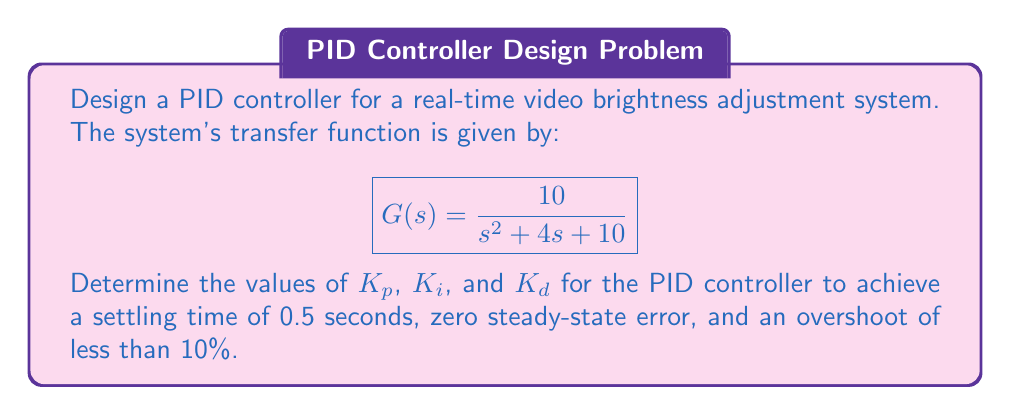Teach me how to tackle this problem. To design a PID controller for this system, we'll follow these steps:

1. Determine the desired closed-loop transfer function based on the given specifications.
2. Calculate the required damping ratio and natural frequency.
3. Design the PID controller using the pole placement method.

Step 1: Desired closed-loop transfer function

For a second-order system, the general form is:

$$T(s) = \frac{\omega_n^2}{s^2 + 2\zeta\omega_n s + \omega_n^2}$$

Where $\zeta$ is the damping ratio and $\omega_n$ is the natural frequency.

Step 2: Calculate damping ratio and natural frequency

For an overshoot of less than 10%, we need $\zeta > 0.59$. Let's choose $\zeta = 0.7$.

The settling time $t_s$ is related to $\zeta$ and $\omega_n$ by:

$$t_s \approx \frac{4}{\zeta\omega_n}$$

Rearranging for $\omega_n$:

$$\omega_n = \frac{4}{\zeta t_s} = \frac{4}{0.7 \cdot 0.5} = 11.43 \text{ rad/s}$$

Step 3: Design PID controller

The PID controller transfer function is:

$$C(s) = K_p + \frac{K_i}{s} + K_d s$$

The closed-loop transfer function with the PID controller is:

$$T(s) = \frac{C(s)G(s)}{1 + C(s)G(s)}$$

Expanding this and equating coefficients with the desired transfer function:

$$\frac{10(K_d s^2 + K_p s + K_i)}{s^3 + (4+10K_d)s^2 + (10+10K_p)s + 10K_i} = \frac{11.43^2}{s^2 + 2(0.7)(11.43)s + 11.43^2}$$

Equating coefficients:

$$10K_d = 1$$
$$4 + 10K_d = 2(0.7)(11.43) = 16$$
$$10 + 10K_p = 11.43^2 = 130.6$$
$$10K_i = 11.43^2 = 130.6$$

Solving these equations:

$$K_d = 0.1$$
$$K_p = 12.06$$
$$K_i = 13.06$$
Answer: The PID controller parameters are:

$K_p = 12.06$
$K_i = 13.06$
$K_d = 0.1$ 